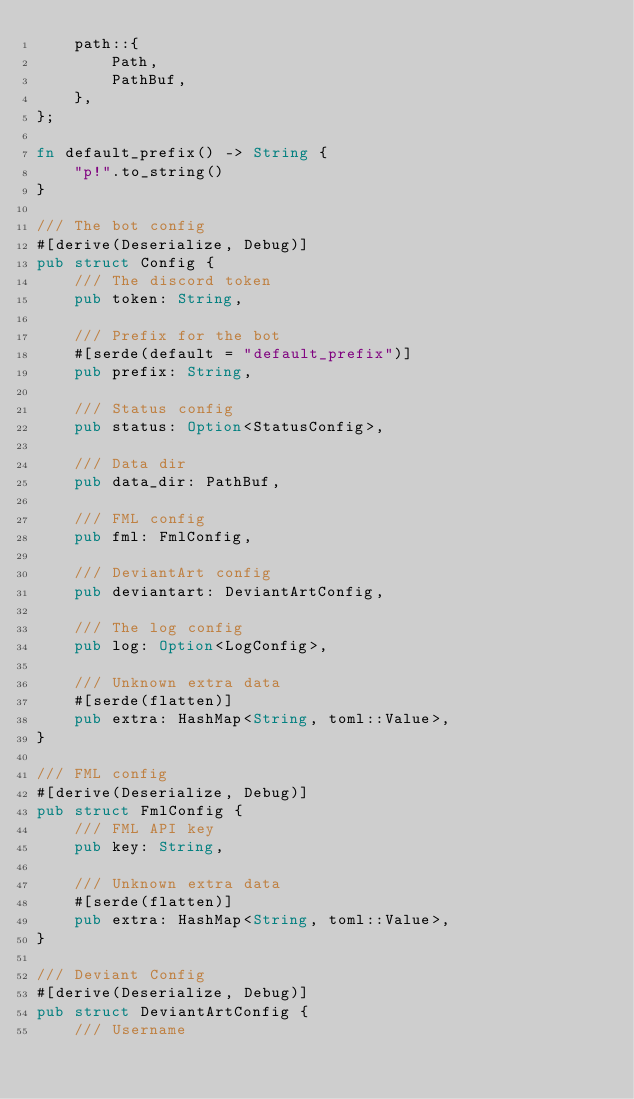Convert code to text. <code><loc_0><loc_0><loc_500><loc_500><_Rust_>    path::{
        Path,
        PathBuf,
    },
};

fn default_prefix() -> String {
    "p!".to_string()
}

/// The bot config
#[derive(Deserialize, Debug)]
pub struct Config {
    /// The discord token
    pub token: String,

    /// Prefix for the bot
    #[serde(default = "default_prefix")]
    pub prefix: String,

    /// Status config
    pub status: Option<StatusConfig>,

    /// Data dir
    pub data_dir: PathBuf,

    /// FML config
    pub fml: FmlConfig,

    /// DeviantArt config
    pub deviantart: DeviantArtConfig,

    /// The log config
    pub log: Option<LogConfig>,

    /// Unknown extra data
    #[serde(flatten)]
    pub extra: HashMap<String, toml::Value>,
}

/// FML config
#[derive(Deserialize, Debug)]
pub struct FmlConfig {
    /// FML API key
    pub key: String,

    /// Unknown extra data
    #[serde(flatten)]
    pub extra: HashMap<String, toml::Value>,
}

/// Deviant Config
#[derive(Deserialize, Debug)]
pub struct DeviantArtConfig {
    /// Username</code> 